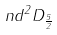<formula> <loc_0><loc_0><loc_500><loc_500>n d ^ { 2 } D _ { \frac { 5 } { 2 } }</formula> 